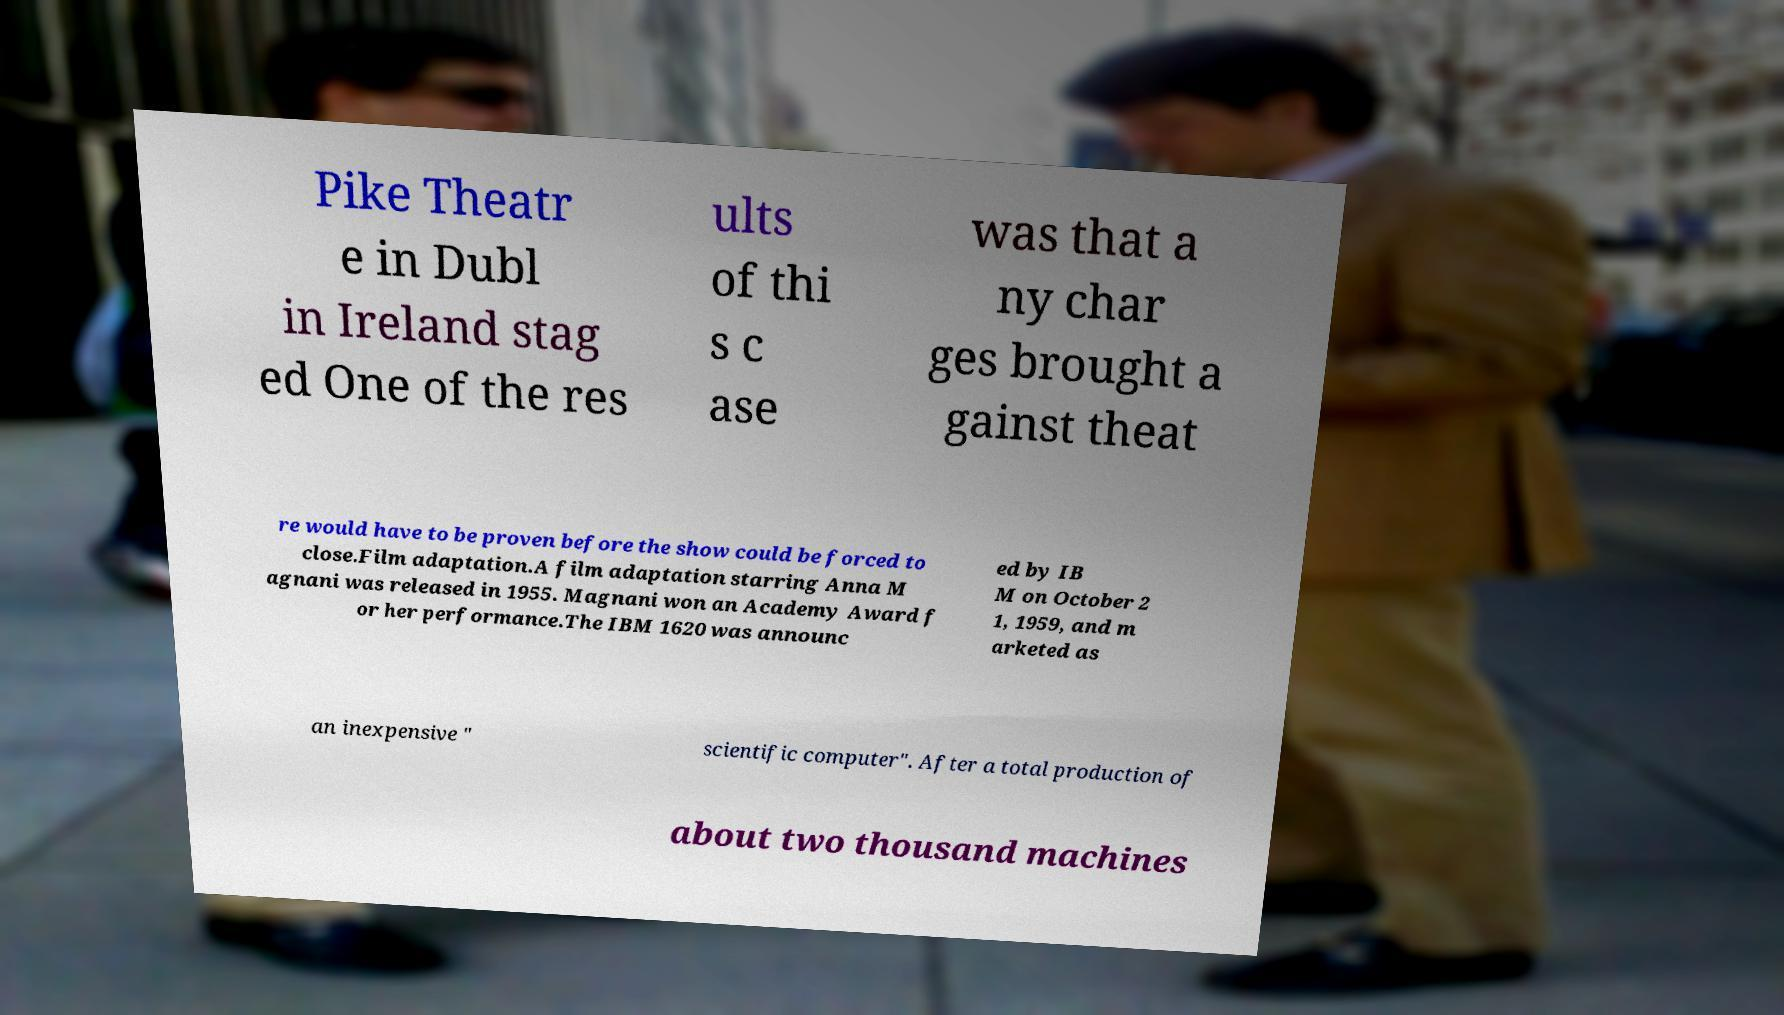Please identify and transcribe the text found in this image. Pike Theatr e in Dubl in Ireland stag ed One of the res ults of thi s c ase was that a ny char ges brought a gainst theat re would have to be proven before the show could be forced to close.Film adaptation.A film adaptation starring Anna M agnani was released in 1955. Magnani won an Academy Award f or her performance.The IBM 1620 was announc ed by IB M on October 2 1, 1959, and m arketed as an inexpensive " scientific computer". After a total production of about two thousand machines 